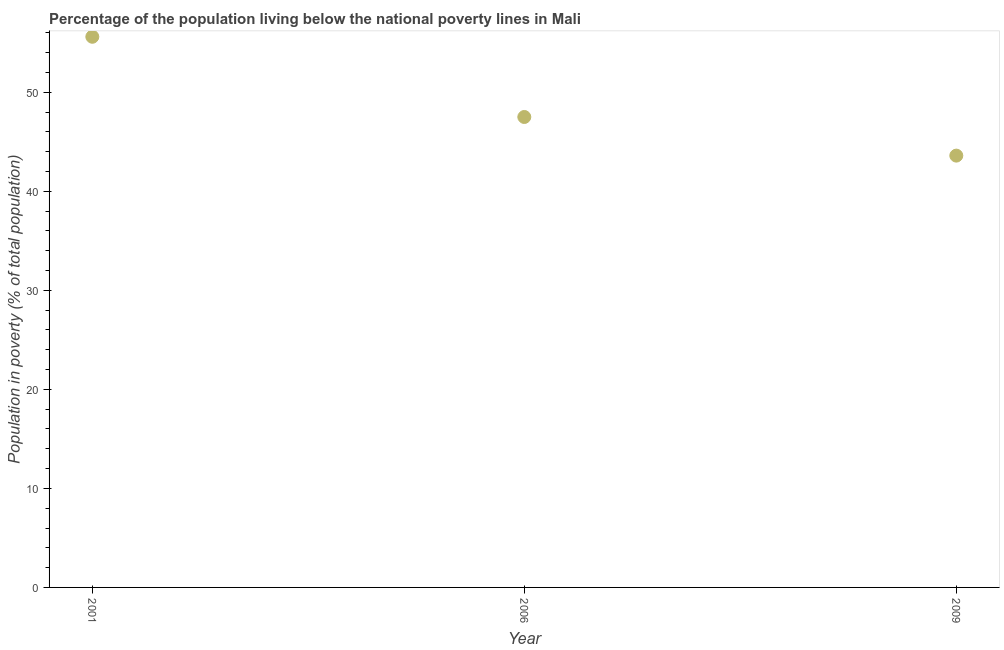What is the percentage of population living below poverty line in 2006?
Offer a very short reply. 47.5. Across all years, what is the maximum percentage of population living below poverty line?
Give a very brief answer. 55.6. Across all years, what is the minimum percentage of population living below poverty line?
Provide a short and direct response. 43.6. What is the sum of the percentage of population living below poverty line?
Offer a terse response. 146.7. What is the difference between the percentage of population living below poverty line in 2001 and 2006?
Your answer should be very brief. 8.1. What is the average percentage of population living below poverty line per year?
Offer a terse response. 48.9. What is the median percentage of population living below poverty line?
Offer a terse response. 47.5. In how many years, is the percentage of population living below poverty line greater than 52 %?
Your answer should be compact. 1. Do a majority of the years between 2009 and 2001 (inclusive) have percentage of population living below poverty line greater than 54 %?
Offer a terse response. No. What is the ratio of the percentage of population living below poverty line in 2006 to that in 2009?
Your response must be concise. 1.09. Is the difference between the percentage of population living below poverty line in 2006 and 2009 greater than the difference between any two years?
Offer a very short reply. No. What is the difference between the highest and the second highest percentage of population living below poverty line?
Provide a short and direct response. 8.1. Does the percentage of population living below poverty line monotonically increase over the years?
Give a very brief answer. No. How many dotlines are there?
Your response must be concise. 1. What is the difference between two consecutive major ticks on the Y-axis?
Keep it short and to the point. 10. Does the graph contain grids?
Your response must be concise. No. What is the title of the graph?
Ensure brevity in your answer.  Percentage of the population living below the national poverty lines in Mali. What is the label or title of the X-axis?
Provide a succinct answer. Year. What is the label or title of the Y-axis?
Ensure brevity in your answer.  Population in poverty (% of total population). What is the Population in poverty (% of total population) in 2001?
Offer a very short reply. 55.6. What is the Population in poverty (% of total population) in 2006?
Offer a terse response. 47.5. What is the Population in poverty (% of total population) in 2009?
Your answer should be very brief. 43.6. What is the ratio of the Population in poverty (% of total population) in 2001 to that in 2006?
Provide a succinct answer. 1.17. What is the ratio of the Population in poverty (% of total population) in 2001 to that in 2009?
Ensure brevity in your answer.  1.27. What is the ratio of the Population in poverty (% of total population) in 2006 to that in 2009?
Give a very brief answer. 1.09. 